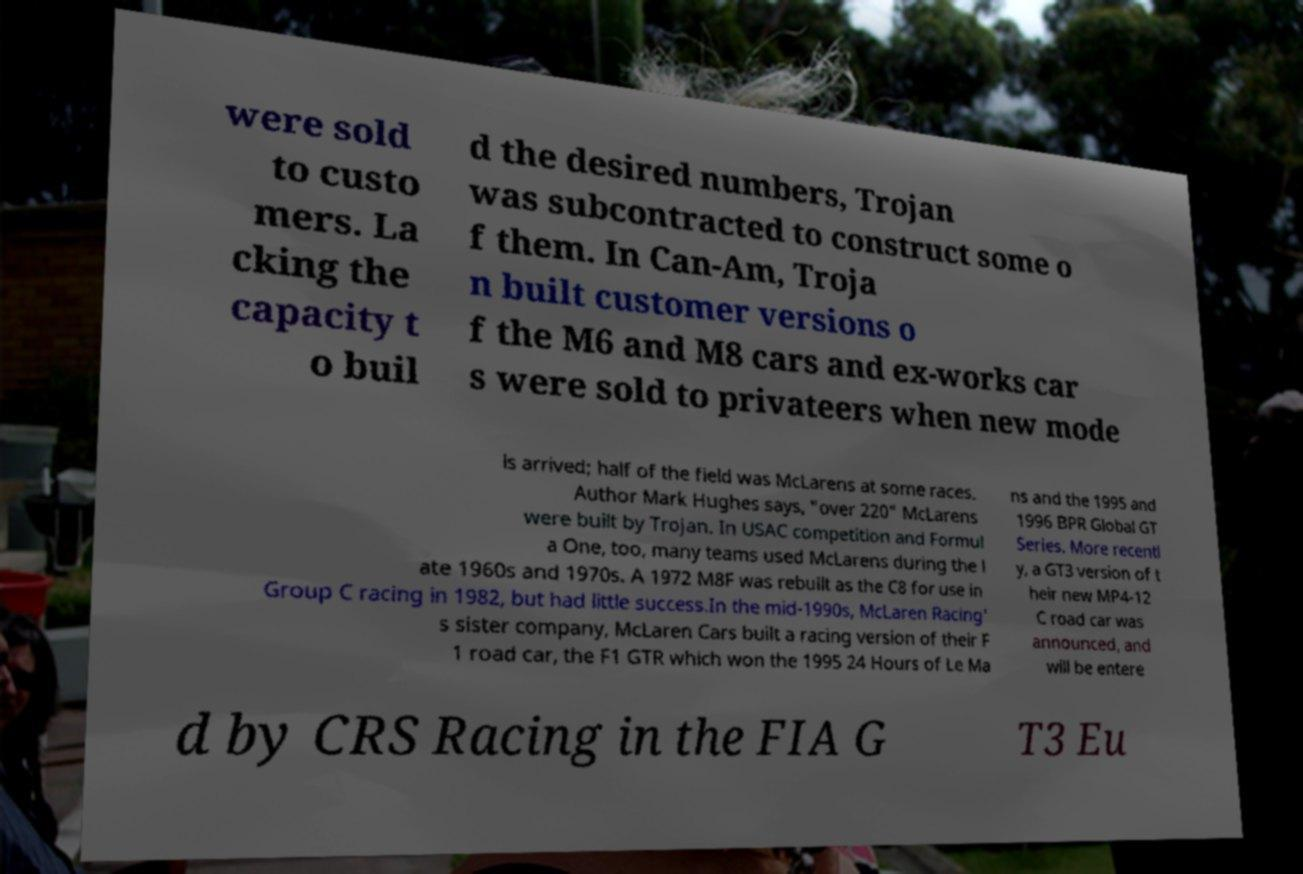Could you assist in decoding the text presented in this image and type it out clearly? were sold to custo mers. La cking the capacity t o buil d the desired numbers, Trojan was subcontracted to construct some o f them. In Can-Am, Troja n built customer versions o f the M6 and M8 cars and ex-works car s were sold to privateers when new mode ls arrived; half of the field was McLarens at some races. Author Mark Hughes says, "over 220" McLarens were built by Trojan. In USAC competition and Formul a One, too, many teams used McLarens during the l ate 1960s and 1970s. A 1972 M8F was rebuilt as the C8 for use in Group C racing in 1982, but had little success.In the mid-1990s, McLaren Racing' s sister company, McLaren Cars built a racing version of their F 1 road car, the F1 GTR which won the 1995 24 Hours of Le Ma ns and the 1995 and 1996 BPR Global GT Series. More recentl y, a GT3 version of t heir new MP4-12 C road car was announced, and will be entere d by CRS Racing in the FIA G T3 Eu 